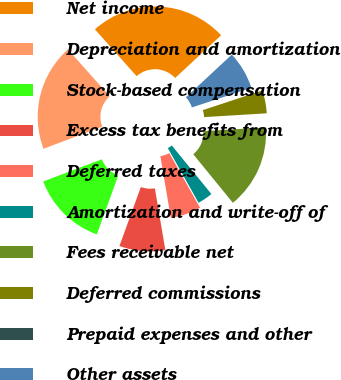Convert chart. <chart><loc_0><loc_0><loc_500><loc_500><pie_chart><fcel>Net income<fcel>Depreciation and amortization<fcel>Stock-based compensation<fcel>Excess tax benefits from<fcel>Deferred taxes<fcel>Amortization and write-off of<fcel>Fees receivable net<fcel>Deferred commissions<fcel>Prepaid expenses and other<fcel>Other assets<nl><fcel>24.66%<fcel>19.18%<fcel>13.7%<fcel>8.22%<fcel>5.48%<fcel>2.74%<fcel>15.07%<fcel>4.11%<fcel>0.0%<fcel>6.85%<nl></chart> 